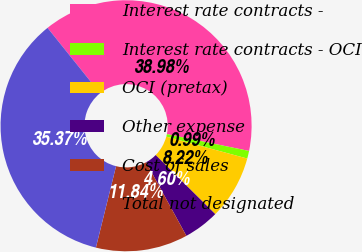Convert chart to OTSL. <chart><loc_0><loc_0><loc_500><loc_500><pie_chart><fcel>Interest rate contracts -<fcel>Interest rate contracts - OCI<fcel>OCI (pretax)<fcel>Other expense<fcel>Cost of sales<fcel>Total not designated<nl><fcel>38.98%<fcel>0.99%<fcel>8.22%<fcel>4.6%<fcel>11.84%<fcel>35.37%<nl></chart> 